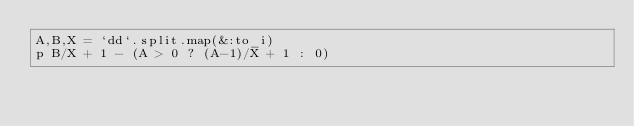Convert code to text. <code><loc_0><loc_0><loc_500><loc_500><_Ruby_>A,B,X = `dd`.split.map(&:to_i)
p B/X + 1 - (A > 0 ? (A-1)/X + 1 : 0)</code> 